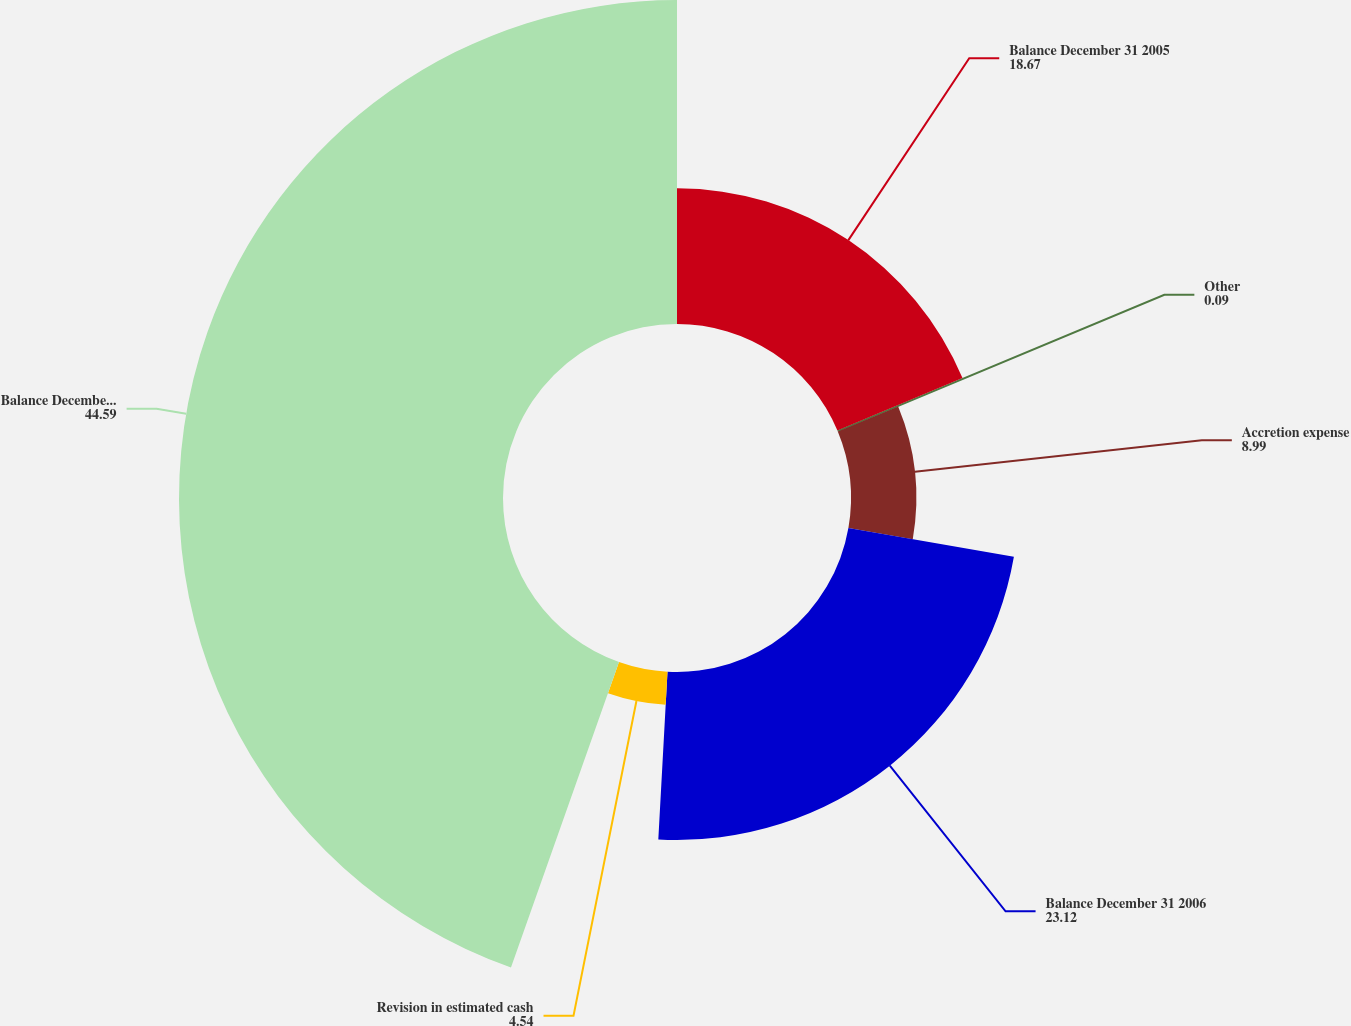Convert chart. <chart><loc_0><loc_0><loc_500><loc_500><pie_chart><fcel>Balance December 31 2005<fcel>Other<fcel>Accretion expense<fcel>Balance December 31 2006<fcel>Revision in estimated cash<fcel>Balance December 31 2007<nl><fcel>18.67%<fcel>0.09%<fcel>8.99%<fcel>23.12%<fcel>4.54%<fcel>44.59%<nl></chart> 